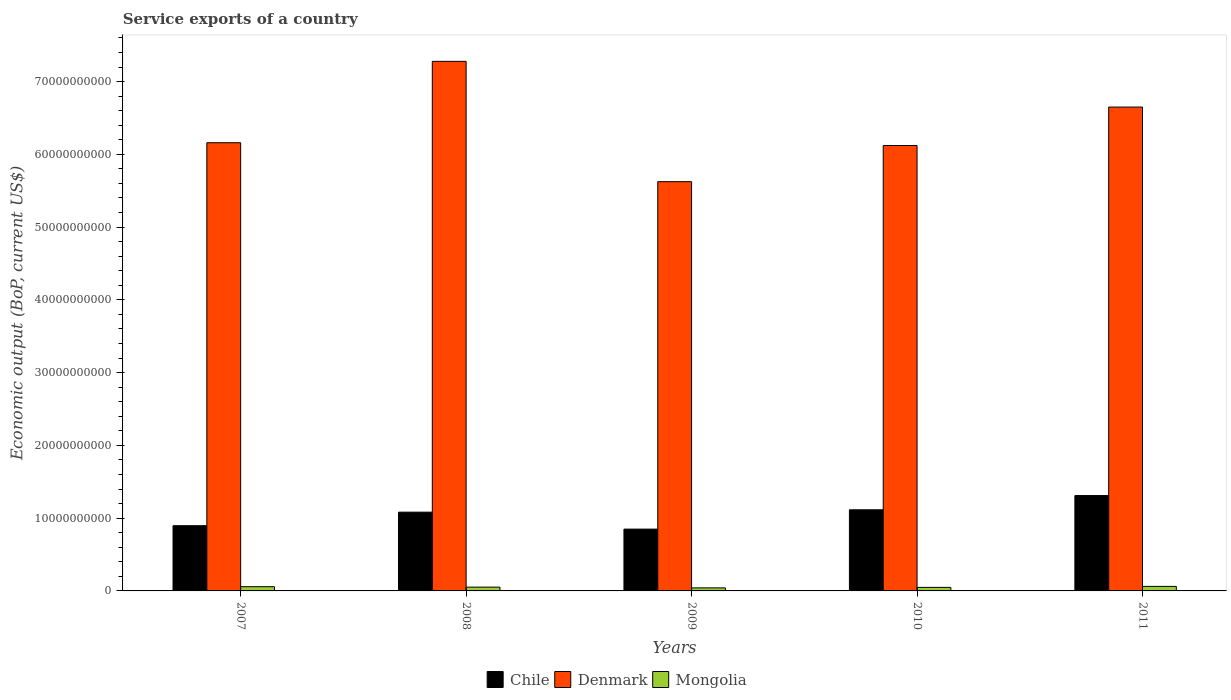How many different coloured bars are there?
Your answer should be very brief. 3. Are the number of bars per tick equal to the number of legend labels?
Ensure brevity in your answer.  Yes. Are the number of bars on each tick of the X-axis equal?
Your response must be concise. Yes. How many bars are there on the 3rd tick from the right?
Offer a very short reply. 3. What is the label of the 5th group of bars from the left?
Make the answer very short. 2011. What is the service exports in Mongolia in 2011?
Your response must be concise. 6.21e+08. Across all years, what is the maximum service exports in Chile?
Offer a very short reply. 1.31e+1. Across all years, what is the minimum service exports in Mongolia?
Your answer should be compact. 4.17e+08. What is the total service exports in Mongolia in the graph?
Ensure brevity in your answer.  2.63e+09. What is the difference between the service exports in Denmark in 2007 and that in 2011?
Provide a succinct answer. -4.90e+09. What is the difference between the service exports in Chile in 2008 and the service exports in Denmark in 2009?
Provide a short and direct response. -4.54e+1. What is the average service exports in Mongolia per year?
Provide a short and direct response. 5.25e+08. In the year 2007, what is the difference between the service exports in Mongolia and service exports in Chile?
Keep it short and to the point. -8.38e+09. What is the ratio of the service exports in Denmark in 2007 to that in 2011?
Make the answer very short. 0.93. Is the difference between the service exports in Mongolia in 2010 and 2011 greater than the difference between the service exports in Chile in 2010 and 2011?
Your answer should be compact. Yes. What is the difference between the highest and the second highest service exports in Chile?
Your answer should be very brief. 1.96e+09. What is the difference between the highest and the lowest service exports in Mongolia?
Ensure brevity in your answer.  2.04e+08. In how many years, is the service exports in Denmark greater than the average service exports in Denmark taken over all years?
Give a very brief answer. 2. Is the sum of the service exports in Denmark in 2008 and 2011 greater than the maximum service exports in Chile across all years?
Make the answer very short. Yes. What does the 1st bar from the left in 2008 represents?
Make the answer very short. Chile. How many bars are there?
Ensure brevity in your answer.  15. What is the difference between two consecutive major ticks on the Y-axis?
Ensure brevity in your answer.  1.00e+1. Are the values on the major ticks of Y-axis written in scientific E-notation?
Your answer should be very brief. No. Does the graph contain any zero values?
Your response must be concise. No. How many legend labels are there?
Make the answer very short. 3. How are the legend labels stacked?
Give a very brief answer. Horizontal. What is the title of the graph?
Provide a succinct answer. Service exports of a country. Does "Namibia" appear as one of the legend labels in the graph?
Provide a succinct answer. No. What is the label or title of the X-axis?
Offer a very short reply. Years. What is the label or title of the Y-axis?
Give a very brief answer. Economic output (BoP, current US$). What is the Economic output (BoP, current US$) in Chile in 2007?
Your answer should be very brief. 8.96e+09. What is the Economic output (BoP, current US$) of Denmark in 2007?
Provide a succinct answer. 6.16e+1. What is the Economic output (BoP, current US$) in Mongolia in 2007?
Keep it short and to the point. 5.82e+08. What is the Economic output (BoP, current US$) of Chile in 2008?
Your response must be concise. 1.08e+1. What is the Economic output (BoP, current US$) in Denmark in 2008?
Provide a succinct answer. 7.28e+1. What is the Economic output (BoP, current US$) in Mongolia in 2008?
Offer a very short reply. 5.20e+08. What is the Economic output (BoP, current US$) of Chile in 2009?
Keep it short and to the point. 8.49e+09. What is the Economic output (BoP, current US$) of Denmark in 2009?
Offer a terse response. 5.62e+1. What is the Economic output (BoP, current US$) of Mongolia in 2009?
Offer a very short reply. 4.17e+08. What is the Economic output (BoP, current US$) of Chile in 2010?
Keep it short and to the point. 1.11e+1. What is the Economic output (BoP, current US$) in Denmark in 2010?
Provide a succinct answer. 6.12e+1. What is the Economic output (BoP, current US$) in Mongolia in 2010?
Offer a terse response. 4.86e+08. What is the Economic output (BoP, current US$) in Chile in 2011?
Your answer should be very brief. 1.31e+1. What is the Economic output (BoP, current US$) of Denmark in 2011?
Keep it short and to the point. 6.65e+1. What is the Economic output (BoP, current US$) in Mongolia in 2011?
Provide a short and direct response. 6.21e+08. Across all years, what is the maximum Economic output (BoP, current US$) in Chile?
Give a very brief answer. 1.31e+1. Across all years, what is the maximum Economic output (BoP, current US$) in Denmark?
Keep it short and to the point. 7.28e+1. Across all years, what is the maximum Economic output (BoP, current US$) of Mongolia?
Offer a very short reply. 6.21e+08. Across all years, what is the minimum Economic output (BoP, current US$) in Chile?
Offer a terse response. 8.49e+09. Across all years, what is the minimum Economic output (BoP, current US$) of Denmark?
Provide a short and direct response. 5.62e+1. Across all years, what is the minimum Economic output (BoP, current US$) in Mongolia?
Give a very brief answer. 4.17e+08. What is the total Economic output (BoP, current US$) in Chile in the graph?
Make the answer very short. 5.25e+1. What is the total Economic output (BoP, current US$) in Denmark in the graph?
Ensure brevity in your answer.  3.18e+11. What is the total Economic output (BoP, current US$) of Mongolia in the graph?
Keep it short and to the point. 2.63e+09. What is the difference between the Economic output (BoP, current US$) of Chile in 2007 and that in 2008?
Your answer should be compact. -1.86e+09. What is the difference between the Economic output (BoP, current US$) of Denmark in 2007 and that in 2008?
Ensure brevity in your answer.  -1.12e+1. What is the difference between the Economic output (BoP, current US$) in Mongolia in 2007 and that in 2008?
Your response must be concise. 6.19e+07. What is the difference between the Economic output (BoP, current US$) in Chile in 2007 and that in 2009?
Provide a succinct answer. 4.70e+08. What is the difference between the Economic output (BoP, current US$) in Denmark in 2007 and that in 2009?
Your answer should be compact. 5.35e+09. What is the difference between the Economic output (BoP, current US$) of Mongolia in 2007 and that in 2009?
Your response must be concise. 1.65e+08. What is the difference between the Economic output (BoP, current US$) in Chile in 2007 and that in 2010?
Ensure brevity in your answer.  -2.19e+09. What is the difference between the Economic output (BoP, current US$) in Denmark in 2007 and that in 2010?
Make the answer very short. 3.83e+08. What is the difference between the Economic output (BoP, current US$) in Mongolia in 2007 and that in 2010?
Provide a succinct answer. 9.60e+07. What is the difference between the Economic output (BoP, current US$) in Chile in 2007 and that in 2011?
Offer a terse response. -4.14e+09. What is the difference between the Economic output (BoP, current US$) in Denmark in 2007 and that in 2011?
Your answer should be compact. -4.90e+09. What is the difference between the Economic output (BoP, current US$) in Mongolia in 2007 and that in 2011?
Your response must be concise. -3.95e+07. What is the difference between the Economic output (BoP, current US$) of Chile in 2008 and that in 2009?
Your answer should be very brief. 2.33e+09. What is the difference between the Economic output (BoP, current US$) in Denmark in 2008 and that in 2009?
Your answer should be compact. 1.65e+1. What is the difference between the Economic output (BoP, current US$) in Mongolia in 2008 and that in 2009?
Offer a very short reply. 1.03e+08. What is the difference between the Economic output (BoP, current US$) in Chile in 2008 and that in 2010?
Your answer should be compact. -3.25e+08. What is the difference between the Economic output (BoP, current US$) in Denmark in 2008 and that in 2010?
Provide a succinct answer. 1.16e+1. What is the difference between the Economic output (BoP, current US$) in Mongolia in 2008 and that in 2010?
Keep it short and to the point. 3.40e+07. What is the difference between the Economic output (BoP, current US$) in Chile in 2008 and that in 2011?
Offer a very short reply. -2.28e+09. What is the difference between the Economic output (BoP, current US$) of Denmark in 2008 and that in 2011?
Keep it short and to the point. 6.28e+09. What is the difference between the Economic output (BoP, current US$) in Mongolia in 2008 and that in 2011?
Give a very brief answer. -1.01e+08. What is the difference between the Economic output (BoP, current US$) in Chile in 2009 and that in 2010?
Keep it short and to the point. -2.66e+09. What is the difference between the Economic output (BoP, current US$) of Denmark in 2009 and that in 2010?
Provide a succinct answer. -4.97e+09. What is the difference between the Economic output (BoP, current US$) in Mongolia in 2009 and that in 2010?
Your answer should be compact. -6.87e+07. What is the difference between the Economic output (BoP, current US$) of Chile in 2009 and that in 2011?
Ensure brevity in your answer.  -4.61e+09. What is the difference between the Economic output (BoP, current US$) in Denmark in 2009 and that in 2011?
Offer a very short reply. -1.03e+1. What is the difference between the Economic output (BoP, current US$) of Mongolia in 2009 and that in 2011?
Offer a very short reply. -2.04e+08. What is the difference between the Economic output (BoP, current US$) in Chile in 2010 and that in 2011?
Provide a short and direct response. -1.96e+09. What is the difference between the Economic output (BoP, current US$) of Denmark in 2010 and that in 2011?
Provide a short and direct response. -5.28e+09. What is the difference between the Economic output (BoP, current US$) of Mongolia in 2010 and that in 2011?
Ensure brevity in your answer.  -1.35e+08. What is the difference between the Economic output (BoP, current US$) in Chile in 2007 and the Economic output (BoP, current US$) in Denmark in 2008?
Give a very brief answer. -6.38e+1. What is the difference between the Economic output (BoP, current US$) in Chile in 2007 and the Economic output (BoP, current US$) in Mongolia in 2008?
Your answer should be very brief. 8.44e+09. What is the difference between the Economic output (BoP, current US$) in Denmark in 2007 and the Economic output (BoP, current US$) in Mongolia in 2008?
Give a very brief answer. 6.11e+1. What is the difference between the Economic output (BoP, current US$) in Chile in 2007 and the Economic output (BoP, current US$) in Denmark in 2009?
Keep it short and to the point. -4.73e+1. What is the difference between the Economic output (BoP, current US$) in Chile in 2007 and the Economic output (BoP, current US$) in Mongolia in 2009?
Provide a short and direct response. 8.55e+09. What is the difference between the Economic output (BoP, current US$) in Denmark in 2007 and the Economic output (BoP, current US$) in Mongolia in 2009?
Provide a short and direct response. 6.12e+1. What is the difference between the Economic output (BoP, current US$) of Chile in 2007 and the Economic output (BoP, current US$) of Denmark in 2010?
Your answer should be compact. -5.22e+1. What is the difference between the Economic output (BoP, current US$) in Chile in 2007 and the Economic output (BoP, current US$) in Mongolia in 2010?
Keep it short and to the point. 8.48e+09. What is the difference between the Economic output (BoP, current US$) in Denmark in 2007 and the Economic output (BoP, current US$) in Mongolia in 2010?
Provide a succinct answer. 6.11e+1. What is the difference between the Economic output (BoP, current US$) in Chile in 2007 and the Economic output (BoP, current US$) in Denmark in 2011?
Keep it short and to the point. -5.75e+1. What is the difference between the Economic output (BoP, current US$) in Chile in 2007 and the Economic output (BoP, current US$) in Mongolia in 2011?
Ensure brevity in your answer.  8.34e+09. What is the difference between the Economic output (BoP, current US$) of Denmark in 2007 and the Economic output (BoP, current US$) of Mongolia in 2011?
Keep it short and to the point. 6.10e+1. What is the difference between the Economic output (BoP, current US$) in Chile in 2008 and the Economic output (BoP, current US$) in Denmark in 2009?
Provide a succinct answer. -4.54e+1. What is the difference between the Economic output (BoP, current US$) of Chile in 2008 and the Economic output (BoP, current US$) of Mongolia in 2009?
Your answer should be very brief. 1.04e+1. What is the difference between the Economic output (BoP, current US$) of Denmark in 2008 and the Economic output (BoP, current US$) of Mongolia in 2009?
Your response must be concise. 7.24e+1. What is the difference between the Economic output (BoP, current US$) in Chile in 2008 and the Economic output (BoP, current US$) in Denmark in 2010?
Provide a succinct answer. -5.04e+1. What is the difference between the Economic output (BoP, current US$) in Chile in 2008 and the Economic output (BoP, current US$) in Mongolia in 2010?
Offer a terse response. 1.03e+1. What is the difference between the Economic output (BoP, current US$) of Denmark in 2008 and the Economic output (BoP, current US$) of Mongolia in 2010?
Provide a short and direct response. 7.23e+1. What is the difference between the Economic output (BoP, current US$) of Chile in 2008 and the Economic output (BoP, current US$) of Denmark in 2011?
Offer a very short reply. -5.57e+1. What is the difference between the Economic output (BoP, current US$) of Chile in 2008 and the Economic output (BoP, current US$) of Mongolia in 2011?
Keep it short and to the point. 1.02e+1. What is the difference between the Economic output (BoP, current US$) in Denmark in 2008 and the Economic output (BoP, current US$) in Mongolia in 2011?
Provide a succinct answer. 7.22e+1. What is the difference between the Economic output (BoP, current US$) of Chile in 2009 and the Economic output (BoP, current US$) of Denmark in 2010?
Offer a terse response. -5.27e+1. What is the difference between the Economic output (BoP, current US$) of Chile in 2009 and the Economic output (BoP, current US$) of Mongolia in 2010?
Make the answer very short. 8.01e+09. What is the difference between the Economic output (BoP, current US$) of Denmark in 2009 and the Economic output (BoP, current US$) of Mongolia in 2010?
Your response must be concise. 5.58e+1. What is the difference between the Economic output (BoP, current US$) in Chile in 2009 and the Economic output (BoP, current US$) in Denmark in 2011?
Keep it short and to the point. -5.80e+1. What is the difference between the Economic output (BoP, current US$) of Chile in 2009 and the Economic output (BoP, current US$) of Mongolia in 2011?
Provide a short and direct response. 7.87e+09. What is the difference between the Economic output (BoP, current US$) in Denmark in 2009 and the Economic output (BoP, current US$) in Mongolia in 2011?
Your response must be concise. 5.56e+1. What is the difference between the Economic output (BoP, current US$) in Chile in 2010 and the Economic output (BoP, current US$) in Denmark in 2011?
Provide a succinct answer. -5.53e+1. What is the difference between the Economic output (BoP, current US$) of Chile in 2010 and the Economic output (BoP, current US$) of Mongolia in 2011?
Make the answer very short. 1.05e+1. What is the difference between the Economic output (BoP, current US$) in Denmark in 2010 and the Economic output (BoP, current US$) in Mongolia in 2011?
Offer a terse response. 6.06e+1. What is the average Economic output (BoP, current US$) in Chile per year?
Give a very brief answer. 1.05e+1. What is the average Economic output (BoP, current US$) of Denmark per year?
Ensure brevity in your answer.  6.37e+1. What is the average Economic output (BoP, current US$) of Mongolia per year?
Ensure brevity in your answer.  5.25e+08. In the year 2007, what is the difference between the Economic output (BoP, current US$) in Chile and Economic output (BoP, current US$) in Denmark?
Your answer should be compact. -5.26e+1. In the year 2007, what is the difference between the Economic output (BoP, current US$) of Chile and Economic output (BoP, current US$) of Mongolia?
Your response must be concise. 8.38e+09. In the year 2007, what is the difference between the Economic output (BoP, current US$) of Denmark and Economic output (BoP, current US$) of Mongolia?
Ensure brevity in your answer.  6.10e+1. In the year 2008, what is the difference between the Economic output (BoP, current US$) of Chile and Economic output (BoP, current US$) of Denmark?
Keep it short and to the point. -6.20e+1. In the year 2008, what is the difference between the Economic output (BoP, current US$) of Chile and Economic output (BoP, current US$) of Mongolia?
Your response must be concise. 1.03e+1. In the year 2008, what is the difference between the Economic output (BoP, current US$) of Denmark and Economic output (BoP, current US$) of Mongolia?
Your answer should be compact. 7.23e+1. In the year 2009, what is the difference between the Economic output (BoP, current US$) of Chile and Economic output (BoP, current US$) of Denmark?
Make the answer very short. -4.78e+1. In the year 2009, what is the difference between the Economic output (BoP, current US$) of Chile and Economic output (BoP, current US$) of Mongolia?
Your answer should be compact. 8.08e+09. In the year 2009, what is the difference between the Economic output (BoP, current US$) of Denmark and Economic output (BoP, current US$) of Mongolia?
Ensure brevity in your answer.  5.58e+1. In the year 2010, what is the difference between the Economic output (BoP, current US$) in Chile and Economic output (BoP, current US$) in Denmark?
Offer a very short reply. -5.01e+1. In the year 2010, what is the difference between the Economic output (BoP, current US$) in Chile and Economic output (BoP, current US$) in Mongolia?
Ensure brevity in your answer.  1.07e+1. In the year 2010, what is the difference between the Economic output (BoP, current US$) of Denmark and Economic output (BoP, current US$) of Mongolia?
Offer a terse response. 6.07e+1. In the year 2011, what is the difference between the Economic output (BoP, current US$) of Chile and Economic output (BoP, current US$) of Denmark?
Provide a short and direct response. -5.34e+1. In the year 2011, what is the difference between the Economic output (BoP, current US$) in Chile and Economic output (BoP, current US$) in Mongolia?
Your response must be concise. 1.25e+1. In the year 2011, what is the difference between the Economic output (BoP, current US$) in Denmark and Economic output (BoP, current US$) in Mongolia?
Your answer should be very brief. 6.59e+1. What is the ratio of the Economic output (BoP, current US$) of Chile in 2007 to that in 2008?
Provide a succinct answer. 0.83. What is the ratio of the Economic output (BoP, current US$) of Denmark in 2007 to that in 2008?
Offer a very short reply. 0.85. What is the ratio of the Economic output (BoP, current US$) of Mongolia in 2007 to that in 2008?
Offer a terse response. 1.12. What is the ratio of the Economic output (BoP, current US$) in Chile in 2007 to that in 2009?
Provide a short and direct response. 1.06. What is the ratio of the Economic output (BoP, current US$) in Denmark in 2007 to that in 2009?
Keep it short and to the point. 1.1. What is the ratio of the Economic output (BoP, current US$) of Mongolia in 2007 to that in 2009?
Give a very brief answer. 1.39. What is the ratio of the Economic output (BoP, current US$) of Chile in 2007 to that in 2010?
Your answer should be compact. 0.8. What is the ratio of the Economic output (BoP, current US$) in Mongolia in 2007 to that in 2010?
Keep it short and to the point. 1.2. What is the ratio of the Economic output (BoP, current US$) in Chile in 2007 to that in 2011?
Ensure brevity in your answer.  0.68. What is the ratio of the Economic output (BoP, current US$) of Denmark in 2007 to that in 2011?
Offer a terse response. 0.93. What is the ratio of the Economic output (BoP, current US$) in Mongolia in 2007 to that in 2011?
Ensure brevity in your answer.  0.94. What is the ratio of the Economic output (BoP, current US$) in Chile in 2008 to that in 2009?
Make the answer very short. 1.27. What is the ratio of the Economic output (BoP, current US$) in Denmark in 2008 to that in 2009?
Make the answer very short. 1.29. What is the ratio of the Economic output (BoP, current US$) of Mongolia in 2008 to that in 2009?
Offer a terse response. 1.25. What is the ratio of the Economic output (BoP, current US$) in Chile in 2008 to that in 2010?
Provide a short and direct response. 0.97. What is the ratio of the Economic output (BoP, current US$) in Denmark in 2008 to that in 2010?
Your answer should be compact. 1.19. What is the ratio of the Economic output (BoP, current US$) in Mongolia in 2008 to that in 2010?
Provide a succinct answer. 1.07. What is the ratio of the Economic output (BoP, current US$) of Chile in 2008 to that in 2011?
Make the answer very short. 0.83. What is the ratio of the Economic output (BoP, current US$) in Denmark in 2008 to that in 2011?
Provide a short and direct response. 1.09. What is the ratio of the Economic output (BoP, current US$) of Mongolia in 2008 to that in 2011?
Provide a short and direct response. 0.84. What is the ratio of the Economic output (BoP, current US$) in Chile in 2009 to that in 2010?
Provide a succinct answer. 0.76. What is the ratio of the Economic output (BoP, current US$) in Denmark in 2009 to that in 2010?
Your response must be concise. 0.92. What is the ratio of the Economic output (BoP, current US$) of Mongolia in 2009 to that in 2010?
Your response must be concise. 0.86. What is the ratio of the Economic output (BoP, current US$) in Chile in 2009 to that in 2011?
Provide a succinct answer. 0.65. What is the ratio of the Economic output (BoP, current US$) in Denmark in 2009 to that in 2011?
Make the answer very short. 0.85. What is the ratio of the Economic output (BoP, current US$) of Mongolia in 2009 to that in 2011?
Provide a succinct answer. 0.67. What is the ratio of the Economic output (BoP, current US$) in Chile in 2010 to that in 2011?
Provide a succinct answer. 0.85. What is the ratio of the Economic output (BoP, current US$) of Denmark in 2010 to that in 2011?
Your answer should be very brief. 0.92. What is the ratio of the Economic output (BoP, current US$) in Mongolia in 2010 to that in 2011?
Offer a terse response. 0.78. What is the difference between the highest and the second highest Economic output (BoP, current US$) in Chile?
Ensure brevity in your answer.  1.96e+09. What is the difference between the highest and the second highest Economic output (BoP, current US$) in Denmark?
Your answer should be very brief. 6.28e+09. What is the difference between the highest and the second highest Economic output (BoP, current US$) of Mongolia?
Your response must be concise. 3.95e+07. What is the difference between the highest and the lowest Economic output (BoP, current US$) in Chile?
Offer a terse response. 4.61e+09. What is the difference between the highest and the lowest Economic output (BoP, current US$) of Denmark?
Offer a very short reply. 1.65e+1. What is the difference between the highest and the lowest Economic output (BoP, current US$) in Mongolia?
Offer a terse response. 2.04e+08. 